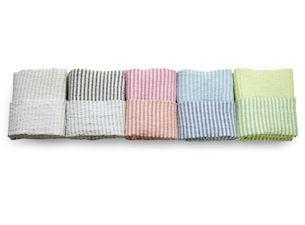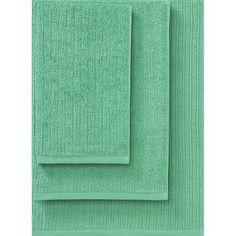The first image is the image on the left, the second image is the image on the right. For the images displayed, is the sentence "Exactly one towel's bottom right corner is folded over." factually correct? Answer yes or no. No. 